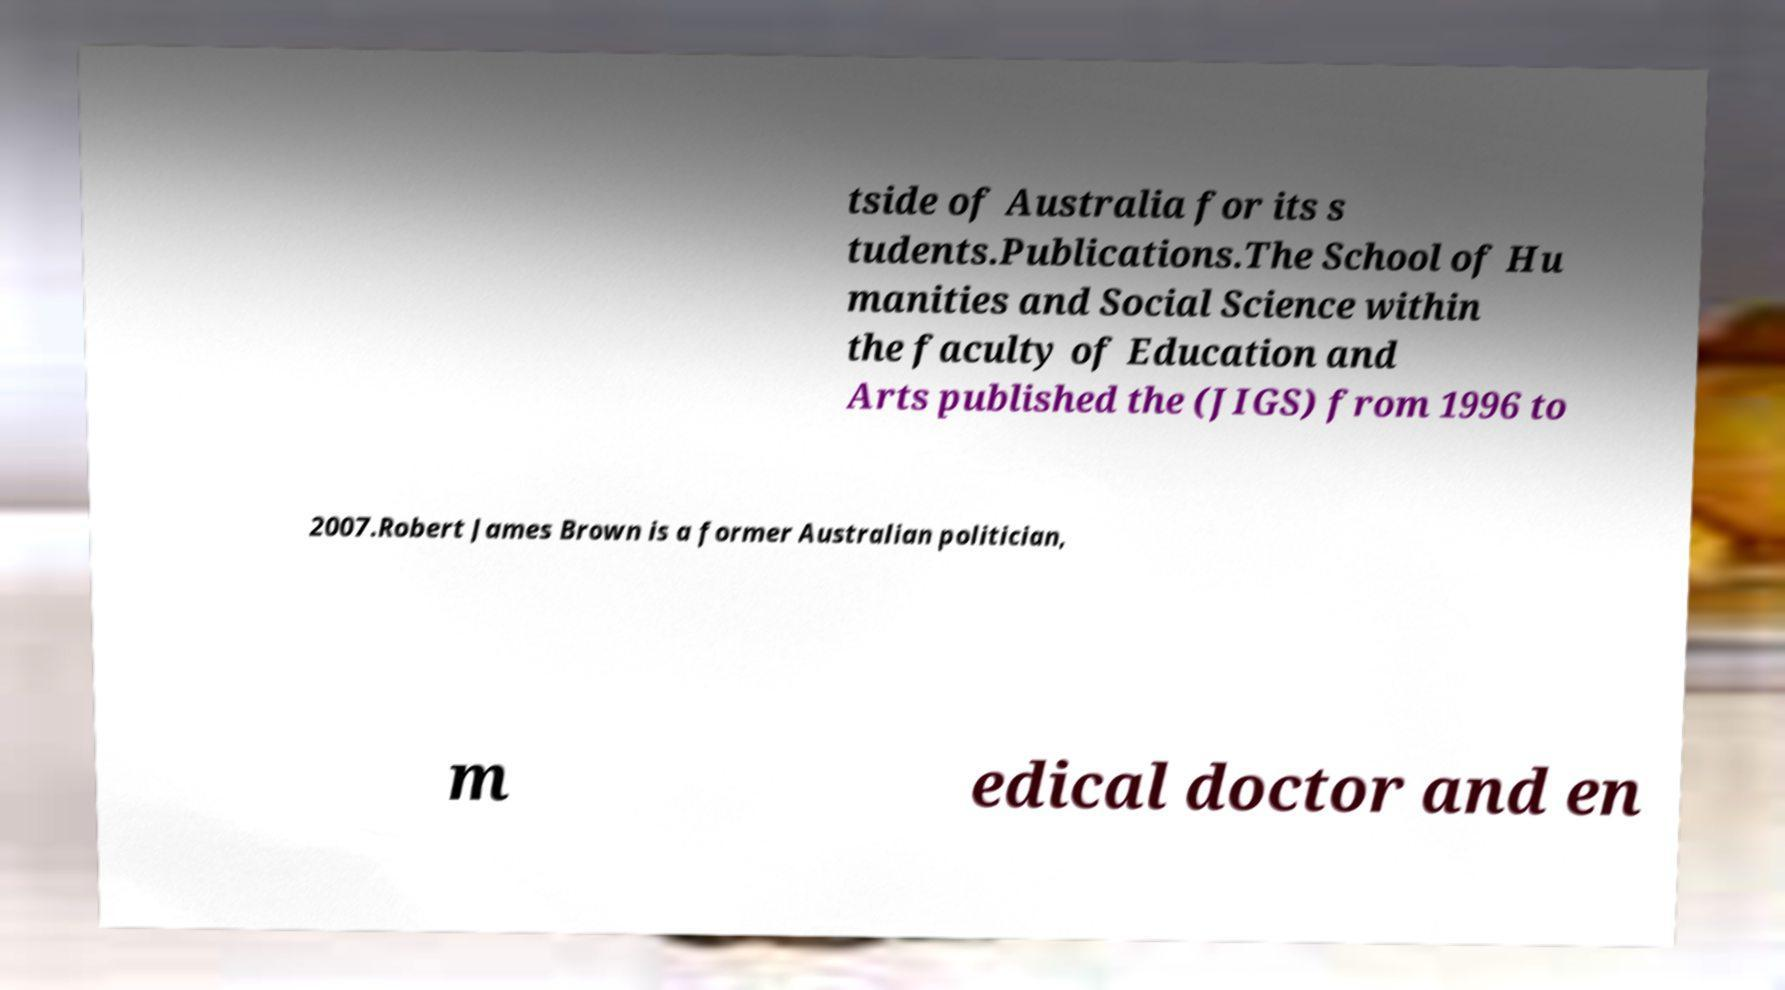Could you assist in decoding the text presented in this image and type it out clearly? tside of Australia for its s tudents.Publications.The School of Hu manities and Social Science within the faculty of Education and Arts published the (JIGS) from 1996 to 2007.Robert James Brown is a former Australian politician, m edical doctor and en 